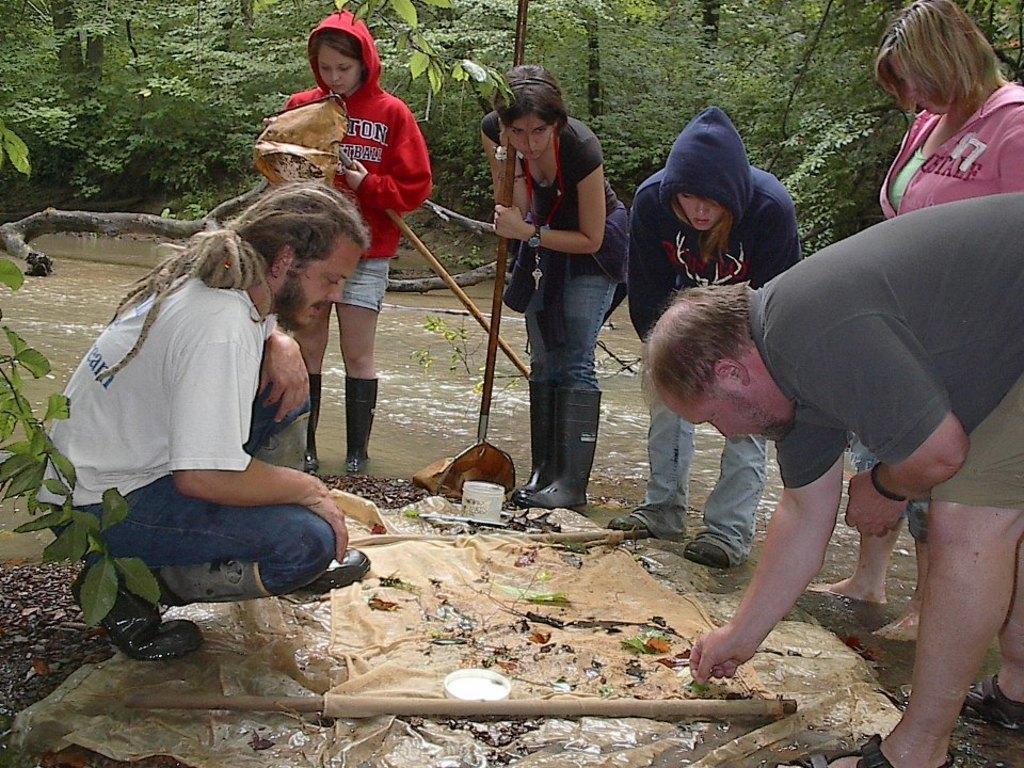In one or two sentences, can you explain what this image depicts? In this picture we can see some people in the front, at the bottom there is a cloth, there are some things present on the cloth, in the background we can see trees, there is water and wood in the middle. 